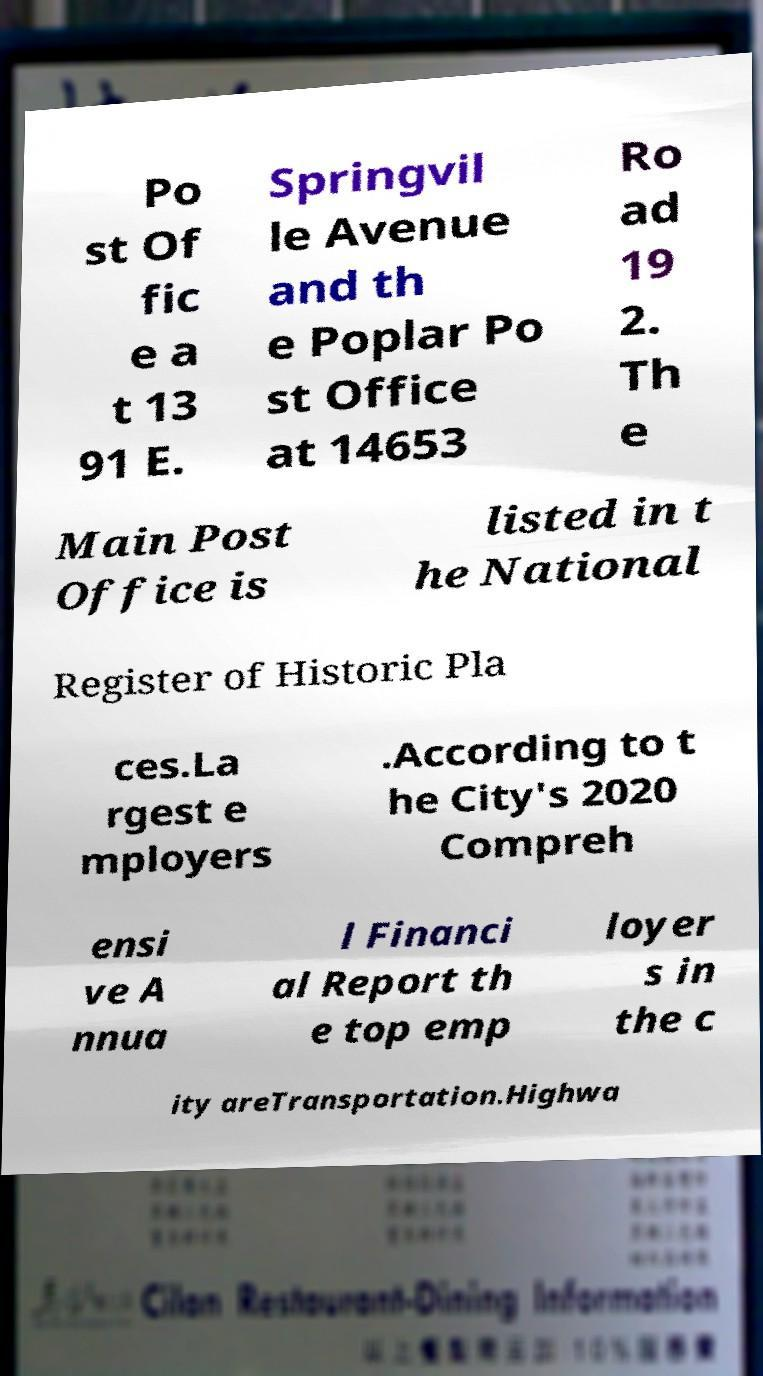Please identify and transcribe the text found in this image. Po st Of fic e a t 13 91 E. Springvil le Avenue and th e Poplar Po st Office at 14653 Ro ad 19 2. Th e Main Post Office is listed in t he National Register of Historic Pla ces.La rgest e mployers .According to t he City's 2020 Compreh ensi ve A nnua l Financi al Report th e top emp loyer s in the c ity areTransportation.Highwa 